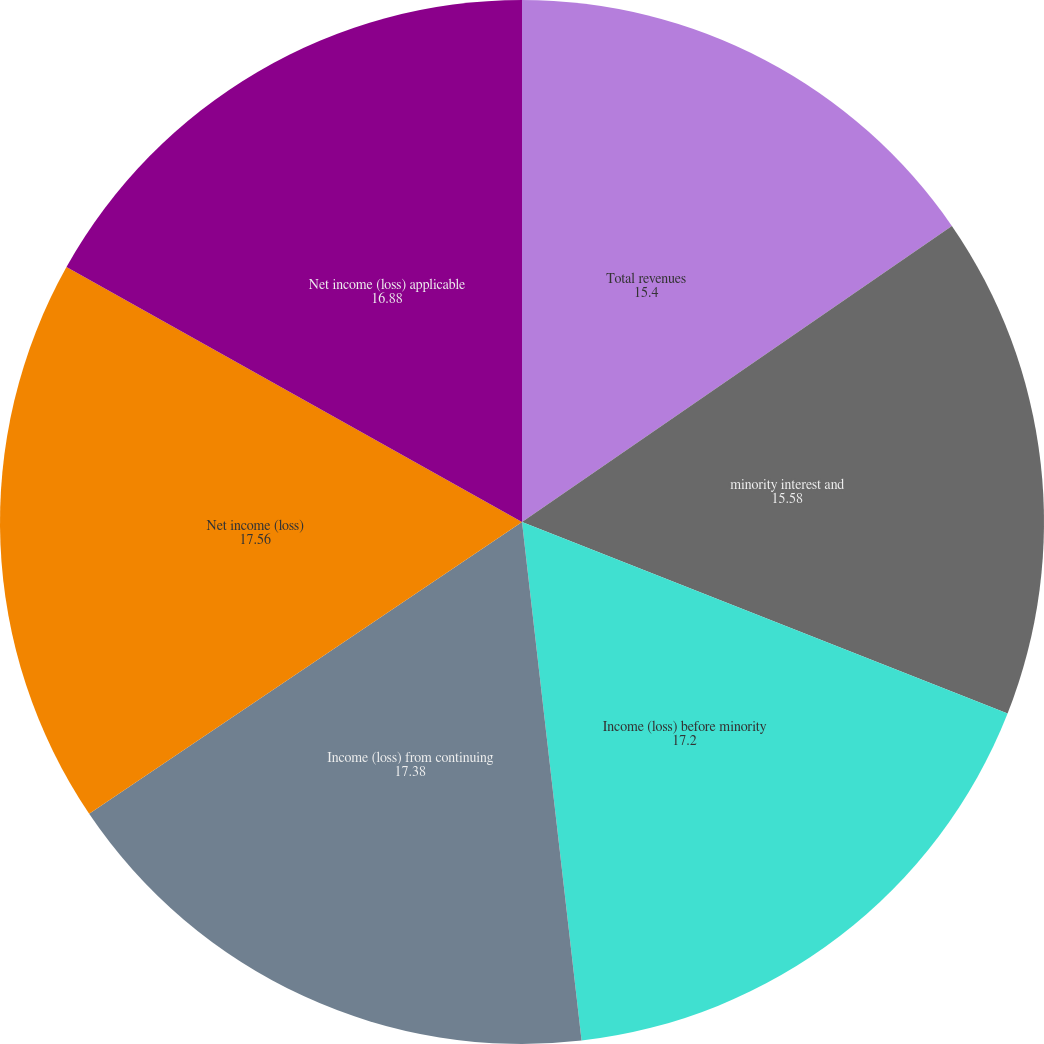<chart> <loc_0><loc_0><loc_500><loc_500><pie_chart><fcel>Total revenues<fcel>minority interest and<fcel>Income (loss) before minority<fcel>Income (loss) from continuing<fcel>Net income (loss)<fcel>Net income (loss) applicable<nl><fcel>15.4%<fcel>15.58%<fcel>17.2%<fcel>17.38%<fcel>17.56%<fcel>16.88%<nl></chart> 